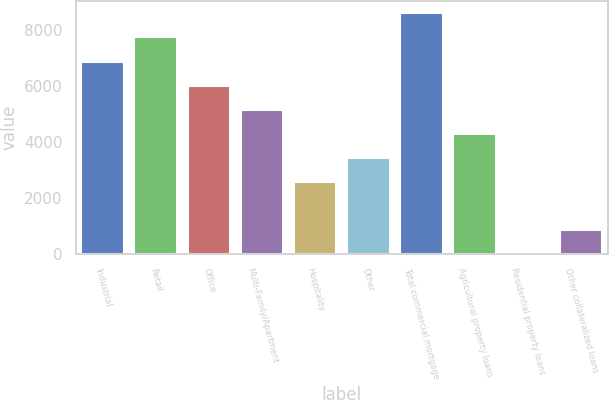Convert chart. <chart><loc_0><loc_0><loc_500><loc_500><bar_chart><fcel>Industrial<fcel>Retail<fcel>Office<fcel>Multi-Family/Apartment<fcel>Hospitality<fcel>Other<fcel>Total commercial mortgage<fcel>Agricultural property loans<fcel>Residential property loans<fcel>Other collateralized loans<nl><fcel>6887.4<fcel>7748.2<fcel>6026.6<fcel>5165.8<fcel>2583.4<fcel>3444.2<fcel>8609<fcel>4305<fcel>1<fcel>861.8<nl></chart> 